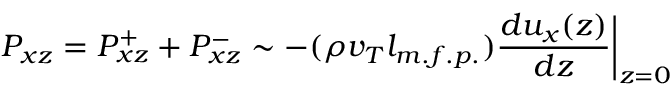Convert formula to latex. <formula><loc_0><loc_0><loc_500><loc_500>P _ { x z } = P _ { x z } ^ { + } + P _ { x z } ^ { - } \sim - ( \rho v _ { T } l _ { m . f . p . } ) \frac { d u _ { x } ( z ) } { d z } \Big | _ { z = 0 }</formula> 